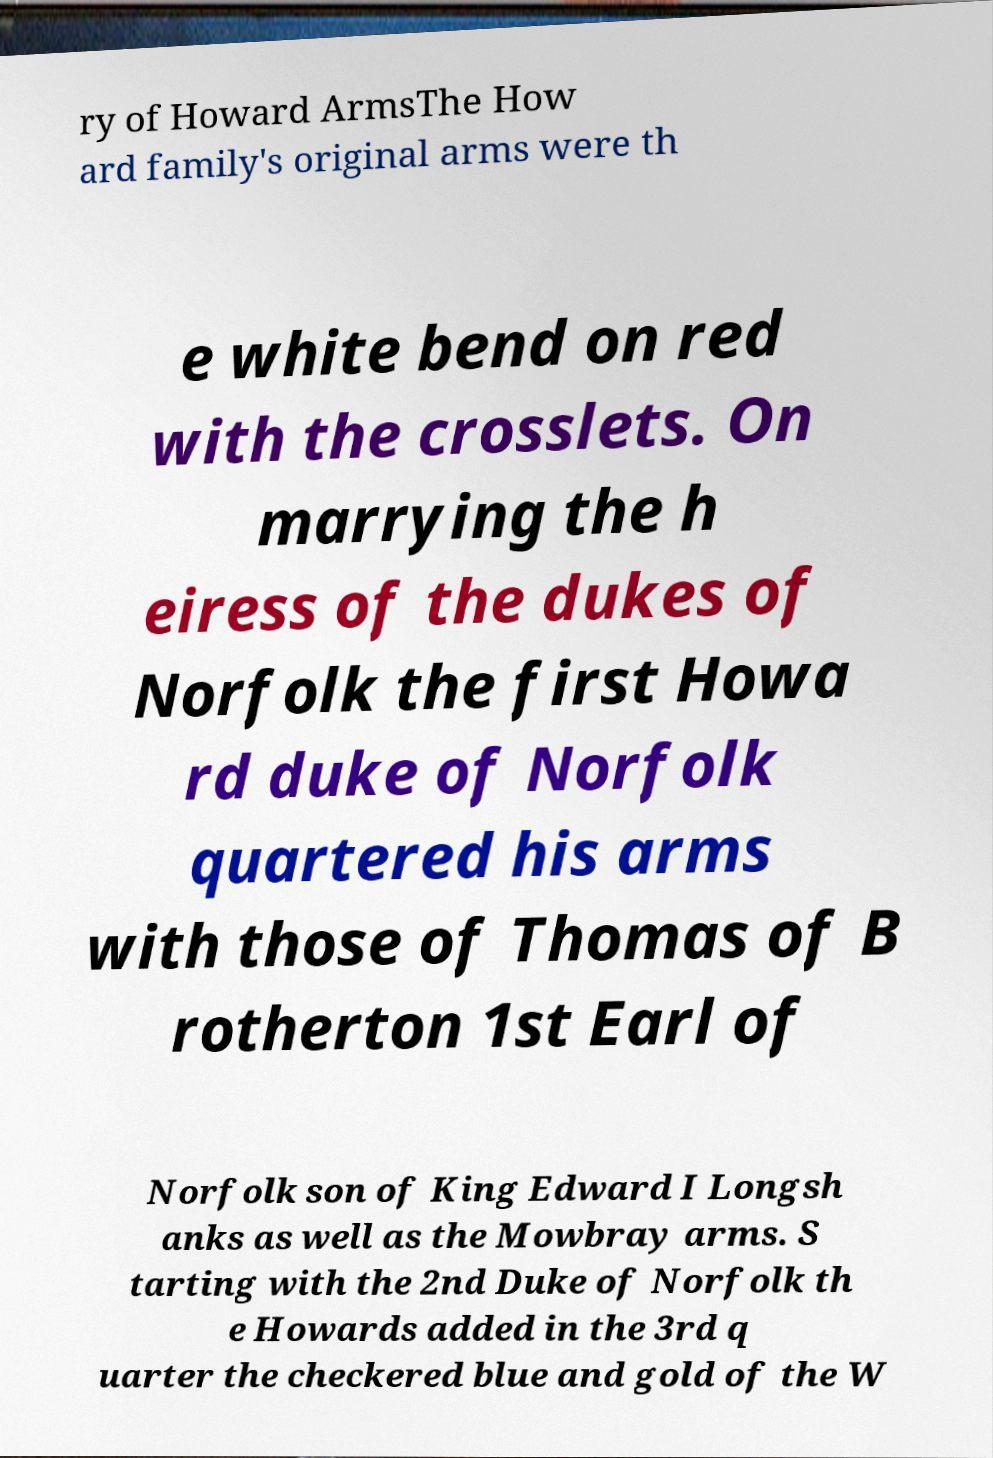There's text embedded in this image that I need extracted. Can you transcribe it verbatim? ry of Howard ArmsThe How ard family's original arms were th e white bend on red with the crosslets. On marrying the h eiress of the dukes of Norfolk the first Howa rd duke of Norfolk quartered his arms with those of Thomas of B rotherton 1st Earl of Norfolk son of King Edward I Longsh anks as well as the Mowbray arms. S tarting with the 2nd Duke of Norfolk th e Howards added in the 3rd q uarter the checkered blue and gold of the W 